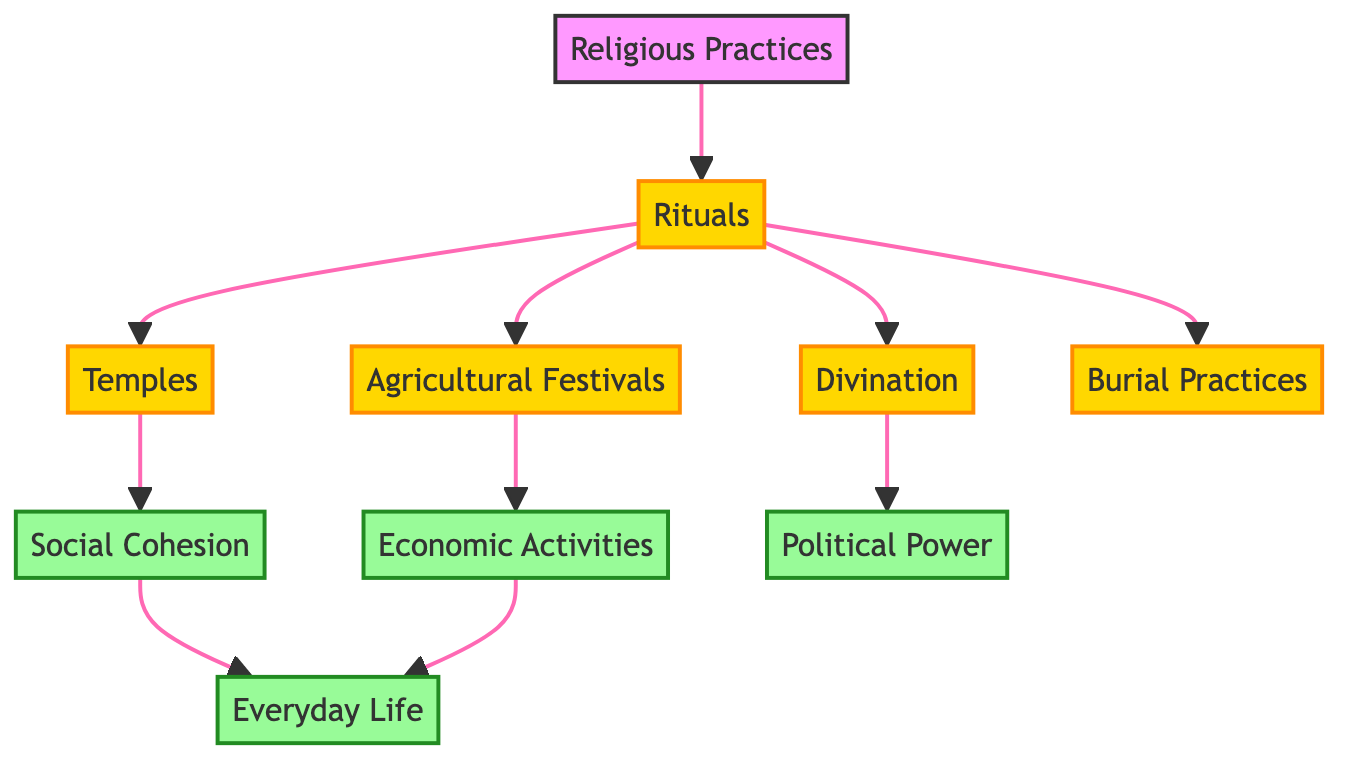What is the total number of nodes in the diagram? The diagram lists ten unique nodes, which include "Religious Practices," "Rituals," "Agricultural Festivals," "Temples," "Social Cohesion," "Economic Activities," "Divination," "Burial Practices," "Political Power," and "Everyday Life."
Answer: 10 What is the edge connecting "Rituals" and "Agricultural Festivals"? There is a directed edge leading from "Rituals" to "Agricultural Festivals," indicating that rituals directly influence agricultural festivals in the context of religious practices.
Answer: Rituals → Agricultural Festivals Which node represents the impact of rituals on daily activities? The "Everyday Life" node indicates the overall impact of various factors, including "Social Cohesion" and "Economic Activities," which are influenced by rituals.
Answer: Everyday Life How many direct influences does "Temples" have? "Temples" has one direct influence, which is "Social Cohesion," demonstrating the relationship between religious structures and the unity within the society.
Answer: 1 Which node connects "Divination" to "Political Power"? The edge from "Divination" to "Political Power" shows that practices related to divination have a direct influence on political authority and leadership in ancient Mesopotamia.
Answer: Divination What societal aspect is influenced by both "Agricultural Festivals" and "Economic Activities"? Both "Agricultural Festivals" and "Economic Activities" directly impact "Everyday Life," illustrating how these economic and religious events shape daily living conditions.
Answer: Everyday Life Which two nodes connect through the edge from "Social Cohesion"? The directed edge from "Social Cohesion" leads to "Everyday Life," meaning that societal unity contributes to shaping the everyday lives of individuals in Mesopotamian cultures.
Answer: Everyday Life What type of practices are indicated by the connections between "Religious Practices" and the rituals that follow? The connections signify that religious practices encompass various rituals including agricultural festivals, divination, and burial practices, suggesting a diverse set of ceremonial activities rooted in the culture.
Answer: Rituals How does "Economic Activities" relate to "Everyday Life"? "Economic Activities" directly impacts "Everyday Life," implying that the economic conditions and practices in ancient Mesopotamia significantly influenced the daily experiences of its inhabitants.
Answer: Everyday Life 